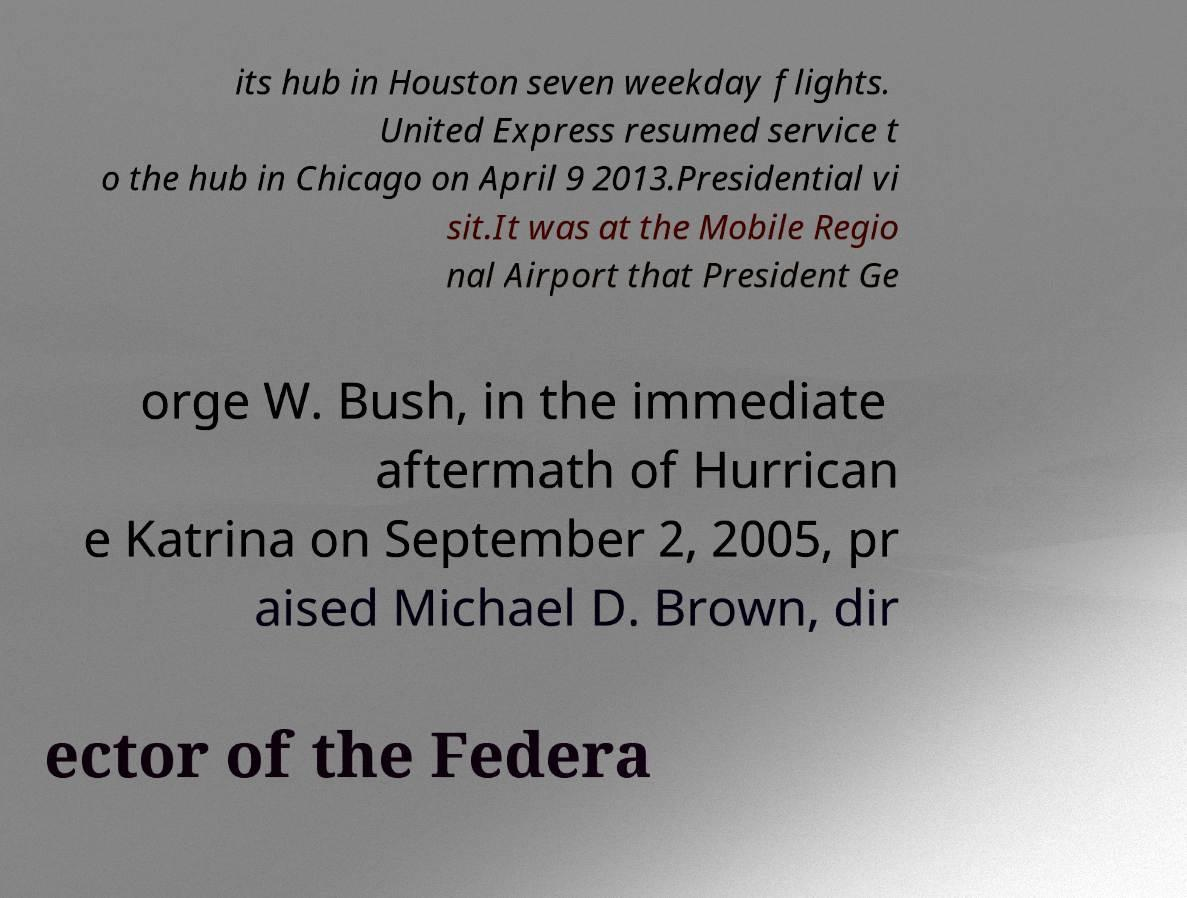I need the written content from this picture converted into text. Can you do that? its hub in Houston seven weekday flights. United Express resumed service t o the hub in Chicago on April 9 2013.Presidential vi sit.It was at the Mobile Regio nal Airport that President Ge orge W. Bush, in the immediate aftermath of Hurrican e Katrina on September 2, 2005, pr aised Michael D. Brown, dir ector of the Federa 